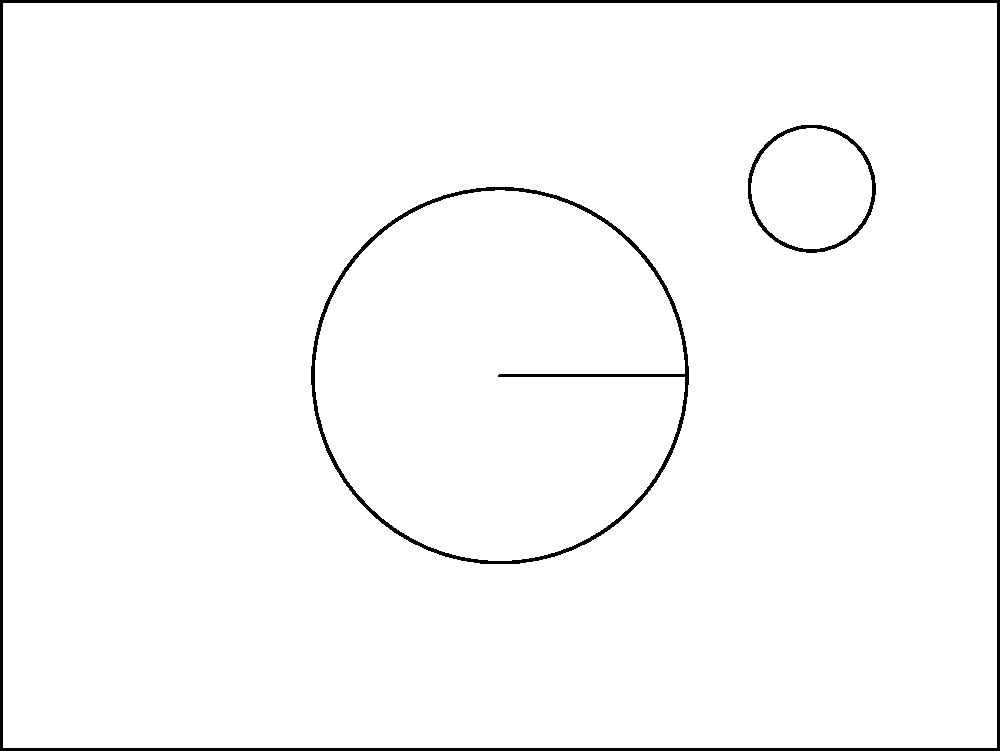In the exploded view diagram of a chronograph mechanism, identify the components labeled A, B, C, and D. Then, explain how these components interact to enable the chronograph function. Which component is crucial for precise timekeeping in a chronograph? To analyze the components and their interactions in a chronograph mechanism:

1. Identify the components:
   A: Chronograph wheel
   B: Column wheel
   C: Lever
   D: Reset hammer

2. Understand the interactions:
   a) The chronograph wheel (A) rotates to measure elapsed time.
   b) The column wheel (B) controls the start, stop, and reset functions.
   c) The lever (C) connects the column wheel to the chronograph wheel, engaging or disengaging the mechanism.
   d) The reset hammer (D) returns the chronograph wheel to zero when activated.

3. Chronograph function:
   - When started, the column wheel (B) rotates, moving the lever (C) to engage the chronograph wheel (A) with the main timekeeping gear train.
   - To stop, the column wheel rotates again, moving the lever to disengage the chronograph wheel.
   - For reset, the column wheel activates the reset hammer (D) to return the chronograph wheel to zero.

4. Crucial component for precise timekeeping:
   The chronograph wheel (A) is crucial for precise timekeeping in a chronograph. It must be precisely calibrated and have minimal friction to accurately measure elapsed time. Its interaction with the main timekeeping gear train through the lever system allows for accurate measurement without affecting the watch's primary timekeeping function.
Answer: Chronograph wheel (A) is crucial for precise timekeeping. 